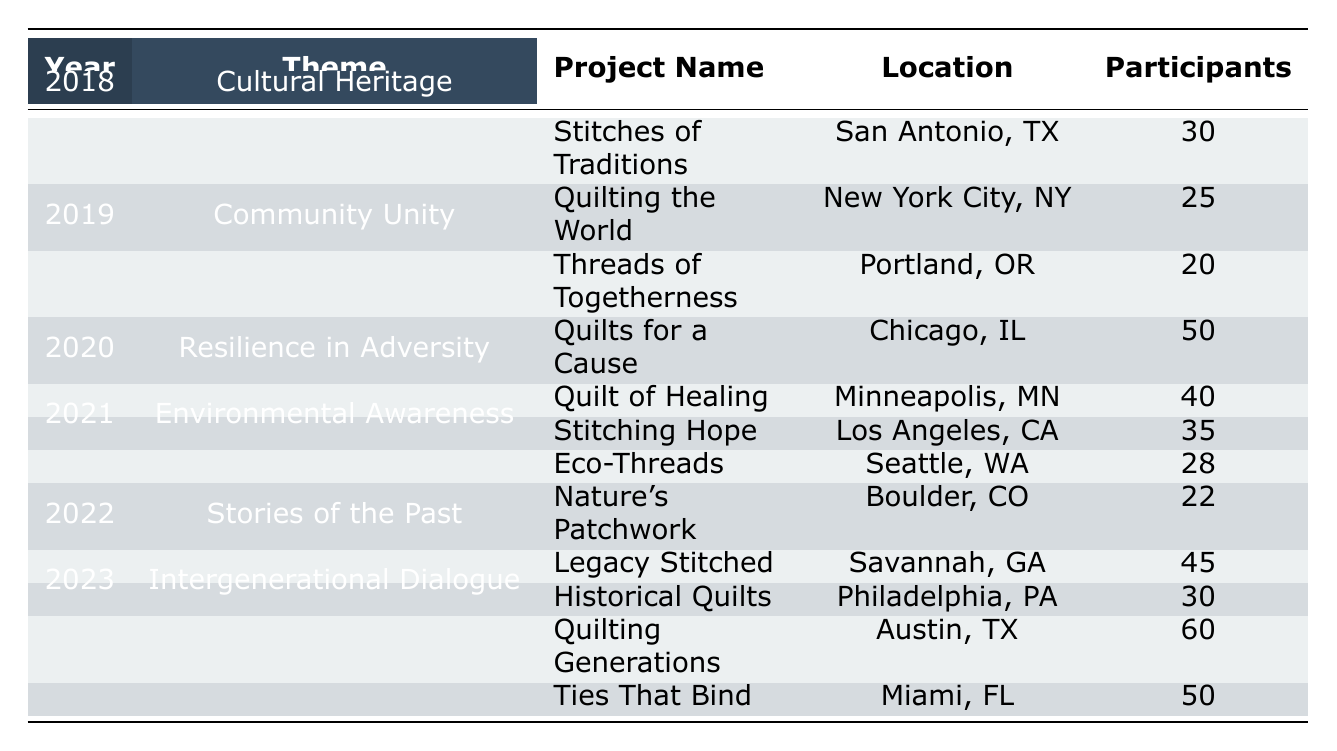What was the theme of the community quilt projects in 2020? The table specifies that the theme for the community quilt projects in 2020 is "Resilience in Adversity."
Answer: Resilience in Adversity Which city hosted the project "Quilts for a Cause"? According to the table, "Quilts for a Cause" was held in Chicago, IL.
Answer: Chicago, IL How many participants were there in total for all projects in 2021? For 2021, the two projects had participants as follows: 28 for "Eco-Threads" and 22 for "Nature's Patchwork." Therefore, the total is 28 + 22 = 50.
Answer: 50 Did the project "Stitching Hope" have more participants than "Legacy Stitched"? "Stitching Hope" had 35 participants, and "Legacy Stitched" had 45 participants. Since 35 is less than 45, the statement is false.
Answer: No What is the average number of participants across all projects in 2019? In 2019, the projects had 20 and 50 participants. To find the average, we sum the participants: 20 + 50 = 70, then divide by the number of projects which is 2, thus the average is 70/2 = 35.
Answer: 35 Which project in 2023 had the highest number of participants? In 2023, the two projects are "Quilting Generations" with 60 participants and "Ties That Bind" with 50 participants. Since 60 is greater than 50, "Quilting Generations" had the highest number.
Answer: Quilting Generations What is the total number of participants from all projects in the "Stories of the Past" theme? The "Stories of the Past" theme includes "Legacy Stitched" with 45 participants and "Historical Quilts" with 30 participants. Summing these gives 45 + 30 = 75 participants total for this theme.
Answer: 75 How many community quilt projects had 30 or more participants in 2022? The year 2022 had "Legacy Stitched" with 45 participants and "Historical Quilts" with 30 participants, therefore there were 2 projects with 30 or more participants.
Answer: 2 